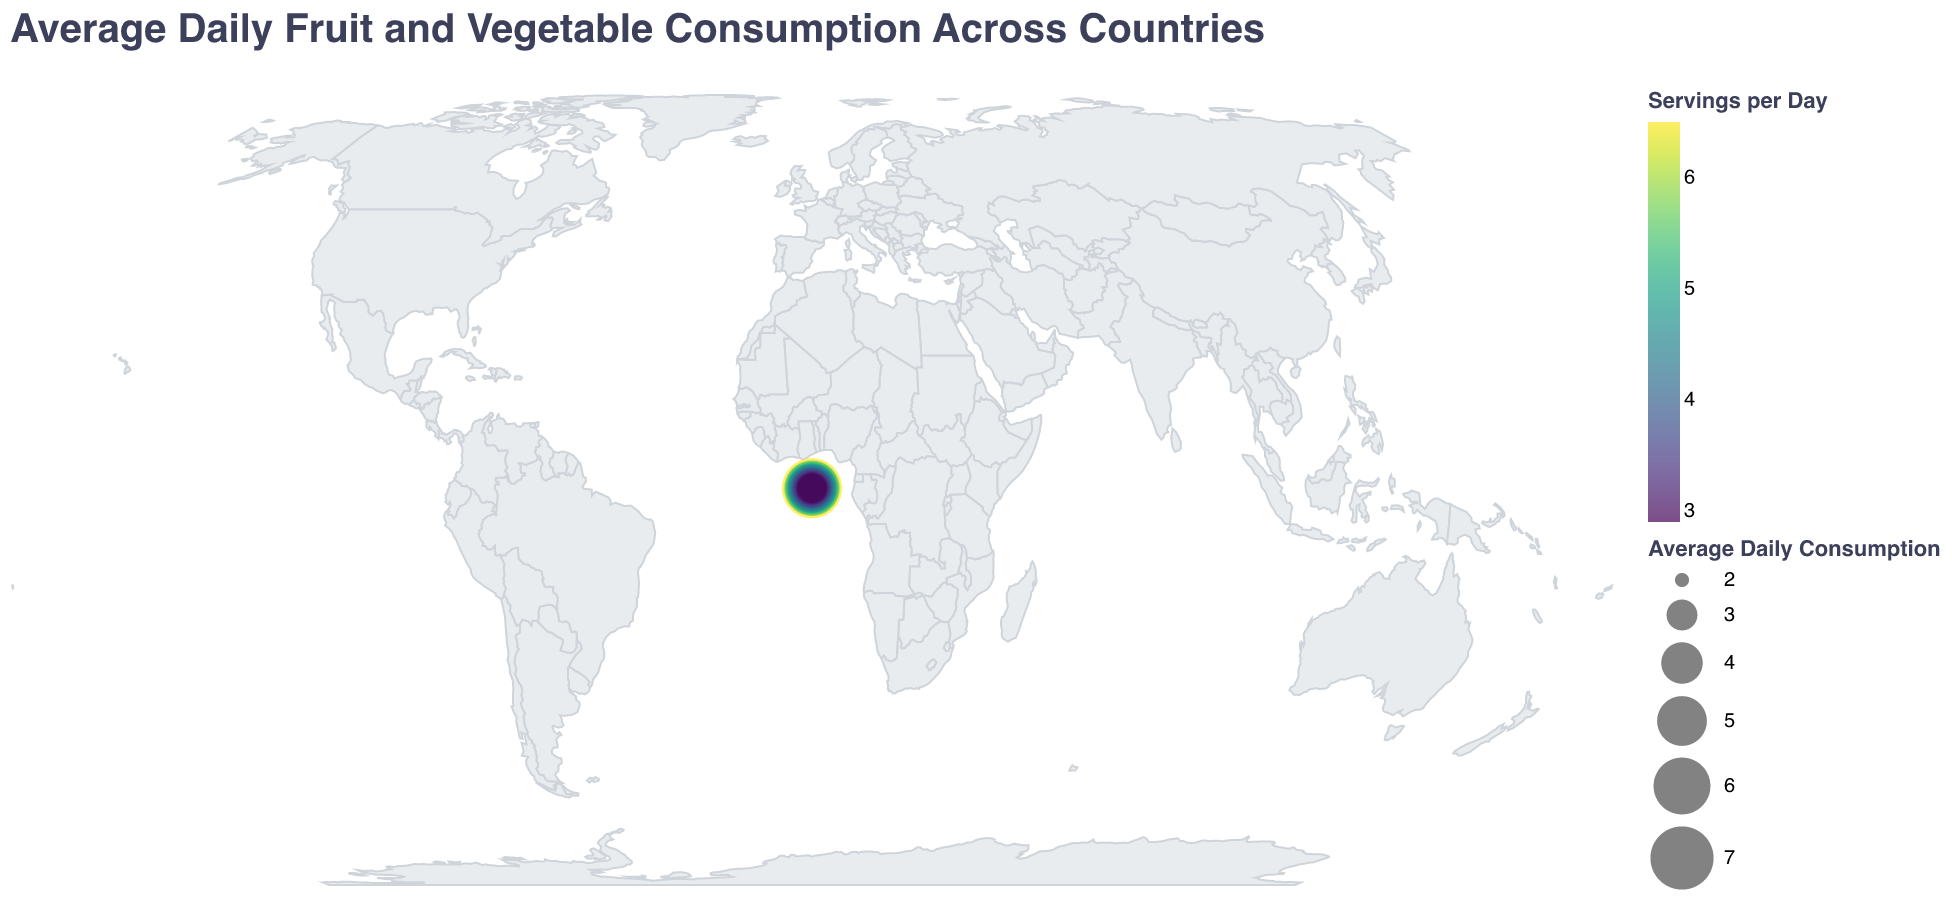What's the title of the figure? The title of the plot is located at the top center of the figure. It reads "Average Daily Fruit and Vegetable Consumption Across Countries."
Answer: Average Daily Fruit and Vegetable Consumption Across Countries Which country has the highest average daily fruit and vegetable consumption? Look at the size and color of the circles representing the countries. The circle for Japan is the largest and the darkest, indicating the highest consumption.
Answer: Japan How does fruit and vegetable consumption in the United States compare to Japan? Compare the size and color of the circles for the United States and Japan. Japan's circle is larger and darker than the United States', indicating higher consumption.
Answer: The United States has lower consumption than Japan What is the average daily fruit and vegetable consumption in France? Locate the circle representing France and check its tooltip or the color/size legend. It is 5.0 servings per day.
Answer: 5.0 servings per day Rank the top three countries by their average daily fruit and vegetable consumption. Refer to the size and color of the circles. The largest and darkest circles represent the top three countries: Japan (6.5), Greece (5.8), and Italy (5.6).
Answer: Japan, Greece, Italy Which country has the lowest average daily fruit and vegetable consumption? Identify the smallest and lightest-colored circle on the figure. That circle represents South Africa, indicating the lowest consumption.
Answer: South Africa What's the average daily fruit and vegetable consumption in Canada and how does it compare to Australia? Check the circles for Canada and Australia. Canada's consumption is 4.7, while Australia's is 4.8.
Answer: Canada has slightly lower consumption (4.7) compared to Australia (4.8) What is the difference in average daily fruit and vegetable consumption between Brazil and Russia? Locate the circles for Brazil and Russia and note their values. Brazil is 3.7, and Russia is 3.3. The difference is 3.7 - 3.3 = 0.4.
Answer: 0.4 servings per day Which region generally consumes more fruits and vegetables, Europe or Asia? Observe the circles for the countries in both regions. European countries like Greece, Italy, and Spain have generally larger and darker circles compared to Asian countries like China and India.
Answer: Europe What is the relative size and color scale indicating on this figure? The size represents the magnitude of average daily fruit and vegetable consumption, while the color gradient from light to dark also shows the intensity of the servings per day. Larger and darker circles mean higher consumption.
Answer: Size and color indicate consumption levels 